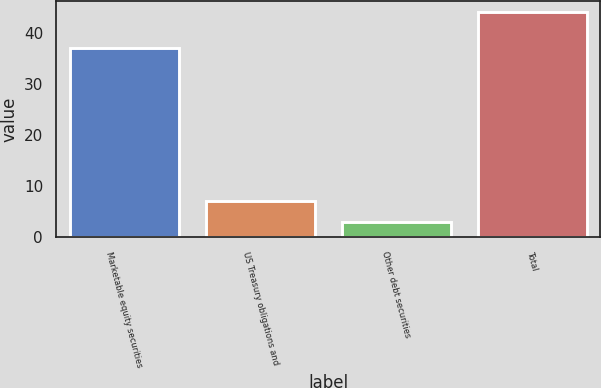Convert chart. <chart><loc_0><loc_0><loc_500><loc_500><bar_chart><fcel>Marketable equity securities<fcel>US Treasury obligations and<fcel>Other debt securities<fcel>Total<nl><fcel>37<fcel>7.1<fcel>3<fcel>44<nl></chart> 